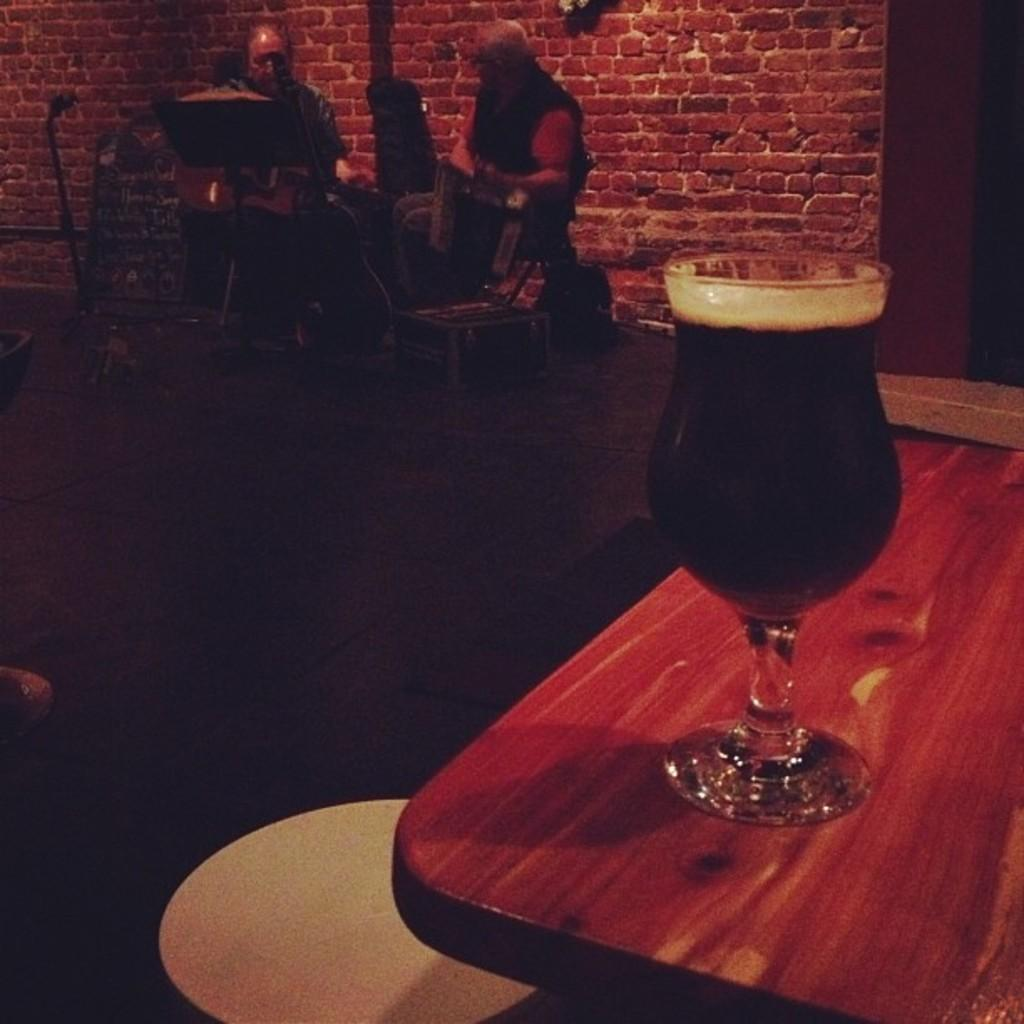What is the main piece of furniture in the image? There is a table in the image. What is on the table? There is a glass with a drink on the table. Can you describe the people in the background of the image? There are two men sitting in the background of the image. What is visible in the background of the image? There is a wall in the background of the image. How would you describe the lighting in the image? The environment is dark. What type of lock is being used by the minister in the image? There is no minister or lock present in the image. 